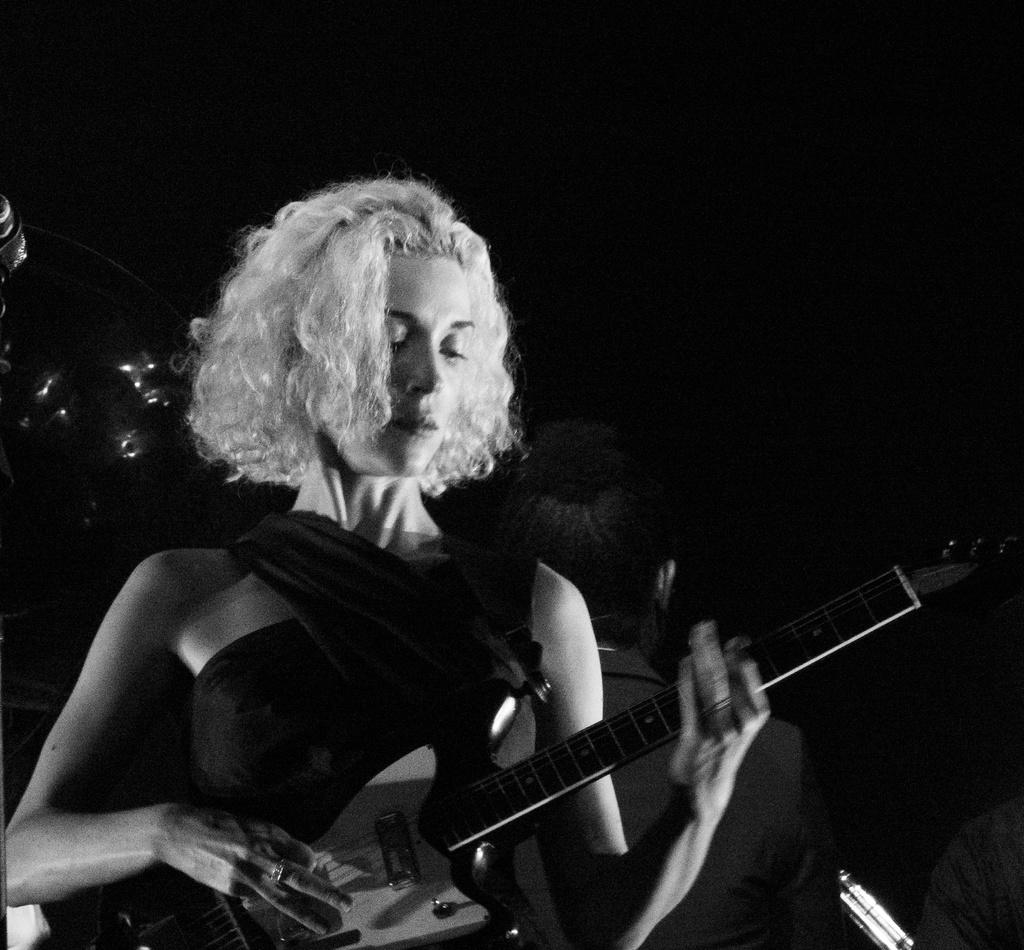What is the color scheme of the image? The image is black and white. Who is the main subject in the image? There is a woman in the image. What is the woman holding in the image? The woman is holding a guitar. Can you describe the background of the image? There are persons in the background of the image. What type of weather can be seen in the image? The image is in black and white, so it is not possible to determine the weather from the image. 